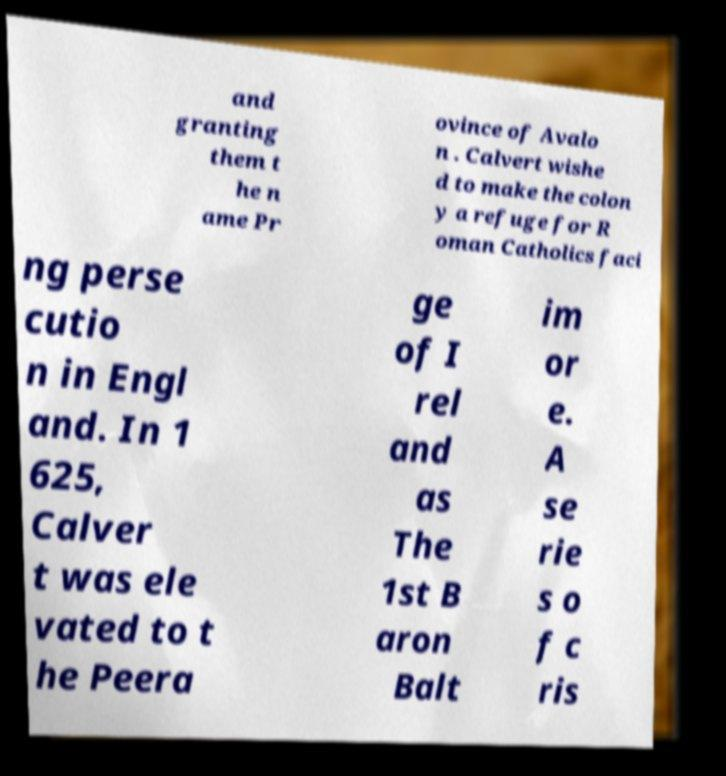Could you assist in decoding the text presented in this image and type it out clearly? and granting them t he n ame Pr ovince of Avalo n . Calvert wishe d to make the colon y a refuge for R oman Catholics faci ng perse cutio n in Engl and. In 1 625, Calver t was ele vated to t he Peera ge of I rel and as The 1st B aron Balt im or e. A se rie s o f c ris 